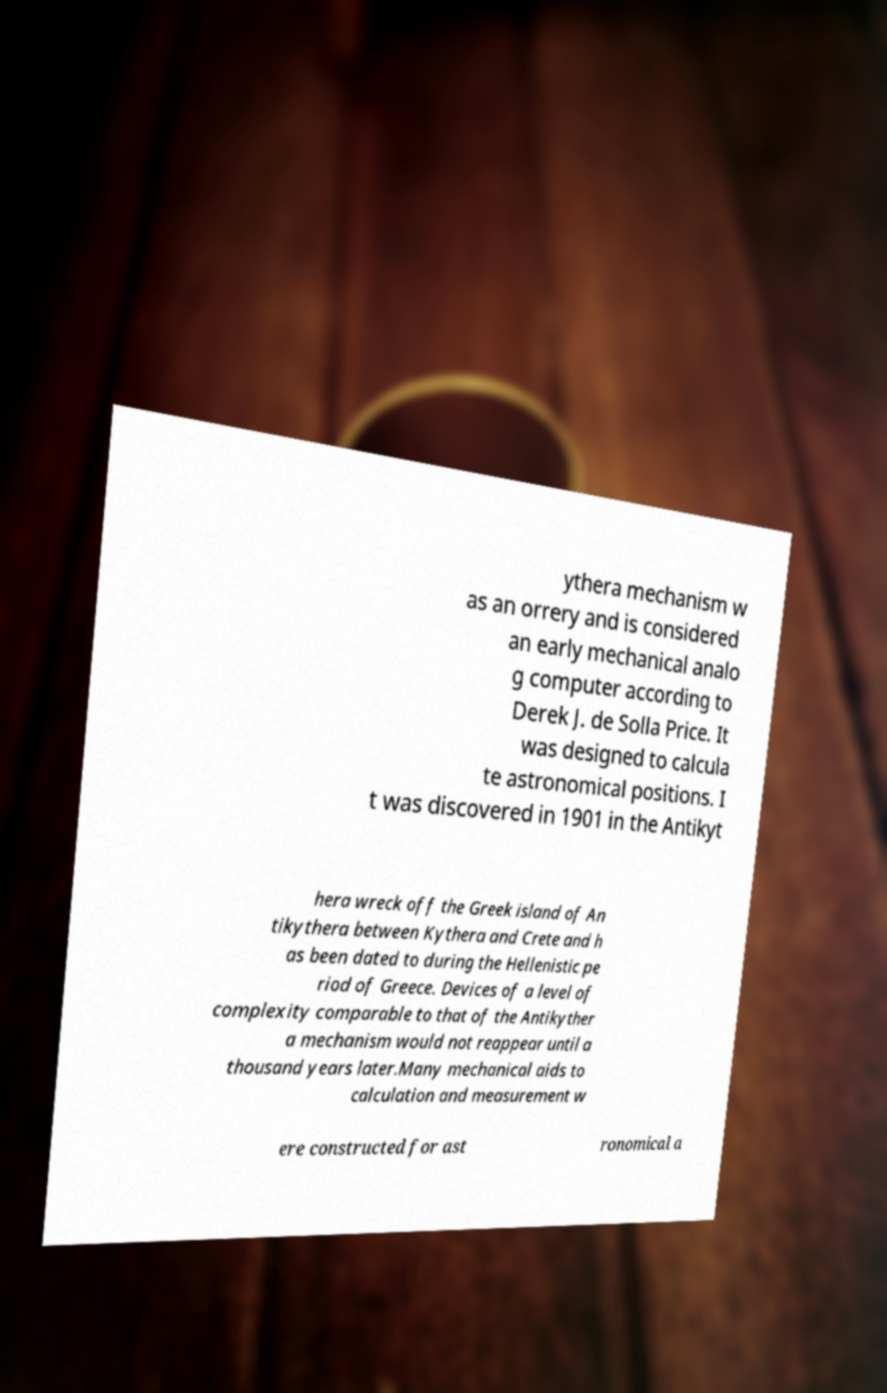Please identify and transcribe the text found in this image. ythera mechanism w as an orrery and is considered an early mechanical analo g computer according to Derek J. de Solla Price. It was designed to calcula te astronomical positions. I t was discovered in 1901 in the Antikyt hera wreck off the Greek island of An tikythera between Kythera and Crete and h as been dated to during the Hellenistic pe riod of Greece. Devices of a level of complexity comparable to that of the Antikyther a mechanism would not reappear until a thousand years later.Many mechanical aids to calculation and measurement w ere constructed for ast ronomical a 